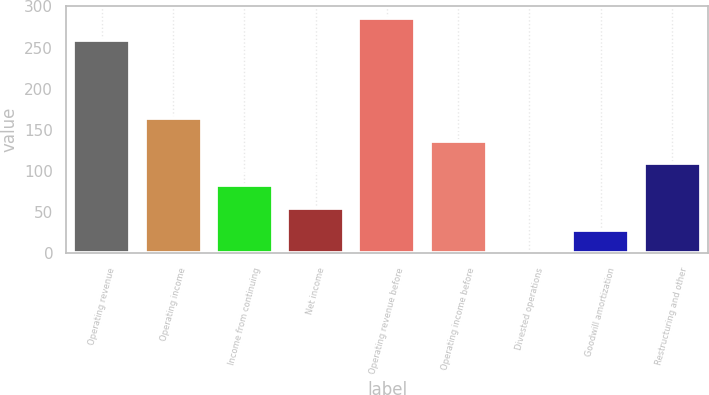<chart> <loc_0><loc_0><loc_500><loc_500><bar_chart><fcel>Operating revenue<fcel>Operating income<fcel>Income from continuing<fcel>Net income<fcel>Operating revenue before<fcel>Operating income before<fcel>Divested operations<fcel>Goodwill amortization<fcel>Restructuring and other<nl><fcel>259<fcel>164.02<fcel>82.66<fcel>55.54<fcel>286.12<fcel>136.9<fcel>1.3<fcel>28.42<fcel>109.78<nl></chart> 